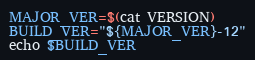Convert code to text. <code><loc_0><loc_0><loc_500><loc_500><_Bash_>MAJOR_VER=$(cat VERSION)
BUILD_VER="${MAJOR_VER}-12"
echo $BUILD_VER

</code> 